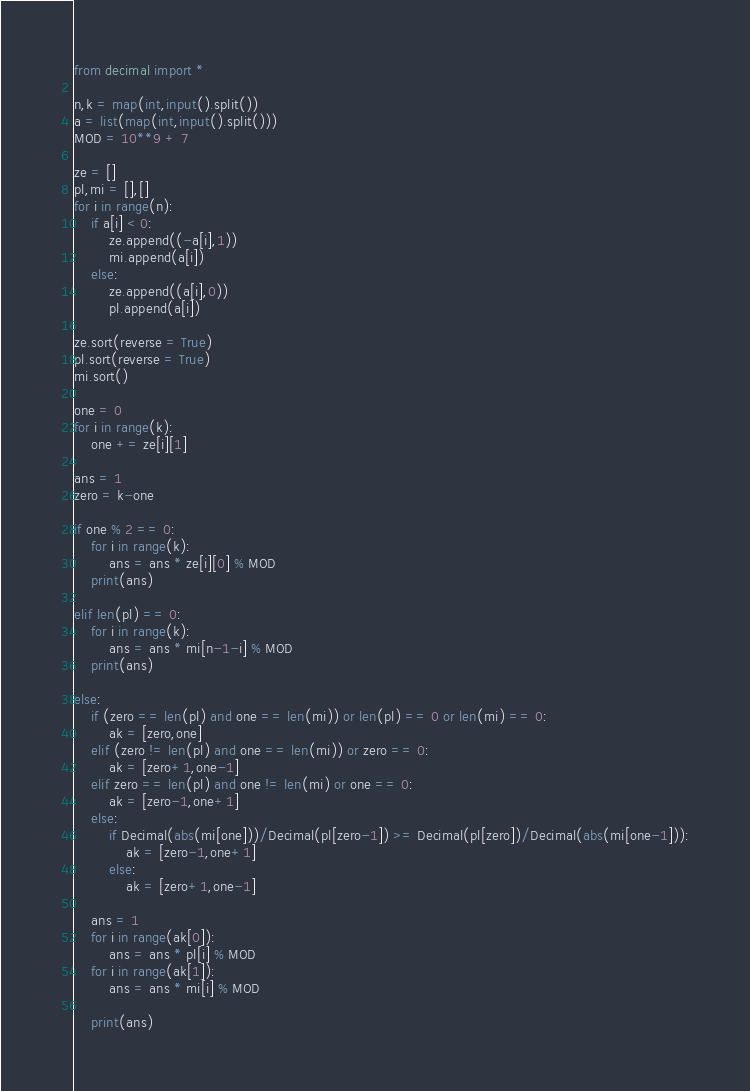<code> <loc_0><loc_0><loc_500><loc_500><_Python_>from decimal import *

n,k = map(int,input().split())
a = list(map(int,input().split()))
MOD = 10**9 + 7

ze = []
pl,mi = [],[]
for i in range(n):
    if a[i] < 0:
        ze.append((-a[i],1))
        mi.append(a[i])
    else:
        ze.append((a[i],0))
        pl.append(a[i])
        
ze.sort(reverse = True)
pl.sort(reverse = True)
mi.sort()

one = 0
for i in range(k):
    one += ze[i][1]
    
ans = 1
zero = k-one

if one % 2 == 0:
    for i in range(k):
        ans = ans * ze[i][0] % MOD
    print(ans)
        
elif len(pl) == 0:
    for i in range(k):
        ans = ans * mi[n-1-i] % MOD
    print(ans)
        
else:
    if (zero == len(pl) and one == len(mi)) or len(pl) == 0 or len(mi) == 0:
        ak = [zero,one]
    elif (zero != len(pl) and one == len(mi)) or zero == 0:
        ak = [zero+1,one-1]
    elif zero == len(pl) and one != len(mi) or one == 0:
        ak = [zero-1,one+1]
    else:
        if Decimal(abs(mi[one]))/Decimal(pl[zero-1]) >= Decimal(pl[zero])/Decimal(abs(mi[one-1])):
            ak = [zero-1,one+1]
        else:
            ak = [zero+1,one-1]
            
    ans = 1
    for i in range(ak[0]):
        ans = ans * pl[i] % MOD
    for i in range(ak[1]):
        ans = ans * mi[i] % MOD
        
    print(ans)</code> 